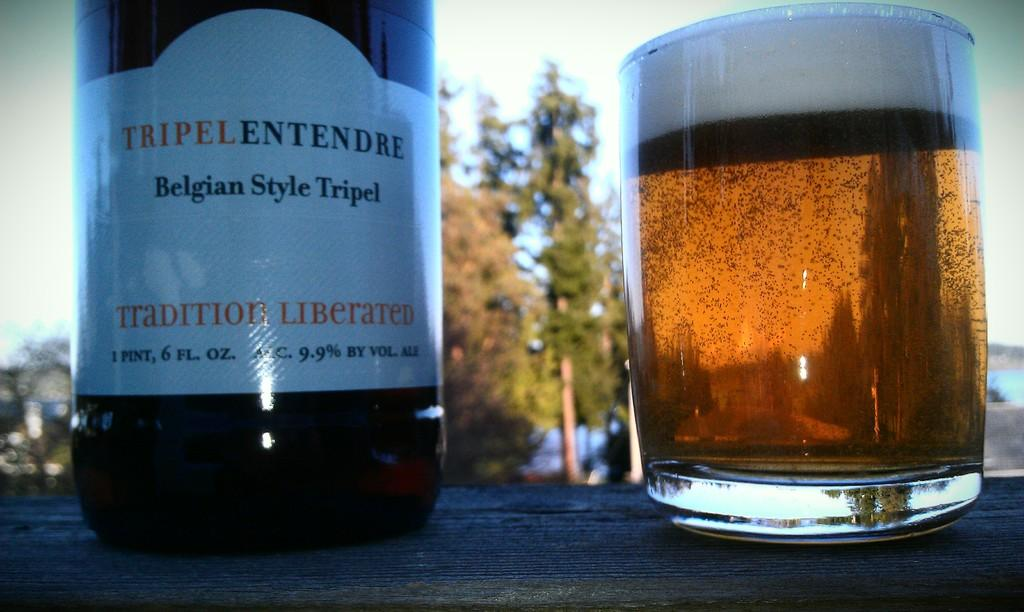<image>
Render a clear and concise summary of the photo. A bottle of Tripe Entendre Belgian Style Tripel on a table next to a small glass full of the Tripel. 